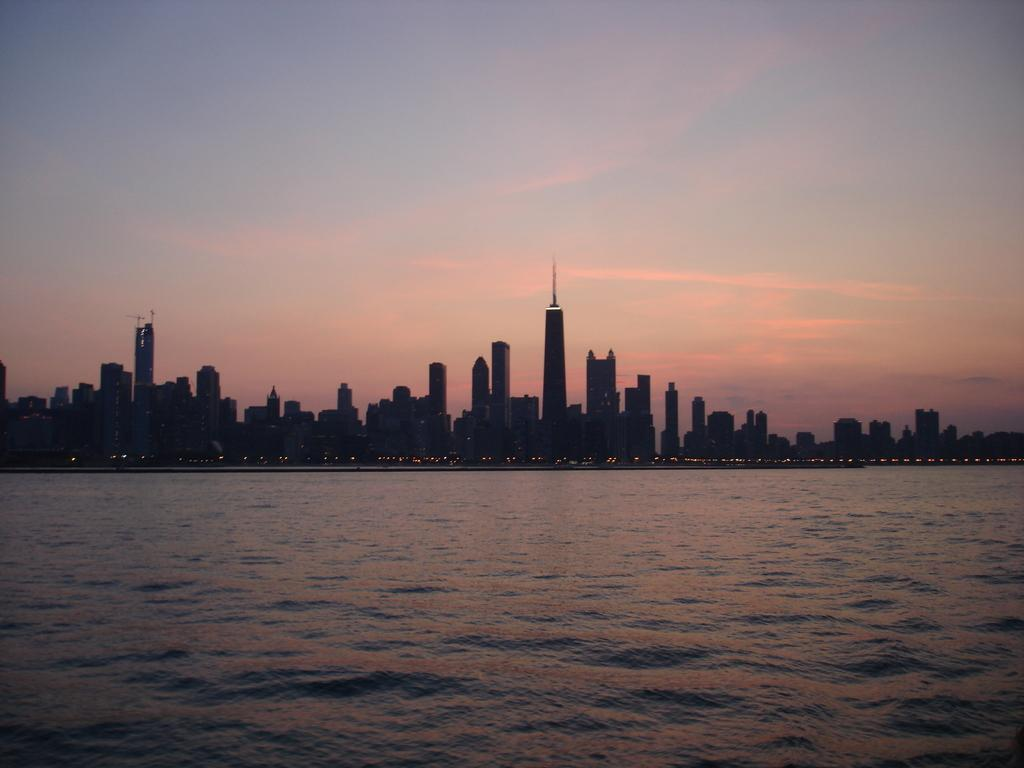What type of buildings can be seen in the image? There are skyscrapers in the image. What natural feature is present at the bottom of the image? There is sea water in the front bottom side of the image. What is the color of the sky in the image? The sunset sky is visible at the top of the image, which means it has warm colors like orange, pink, or red. What type of pest can be seen crawling on the skyscrapers in the image? There are no pests visible on the skyscrapers in the image. What force is causing the sea water to move in the image? The image does not show any movement of the sea water, so it is not possible to determine the force causing it. 